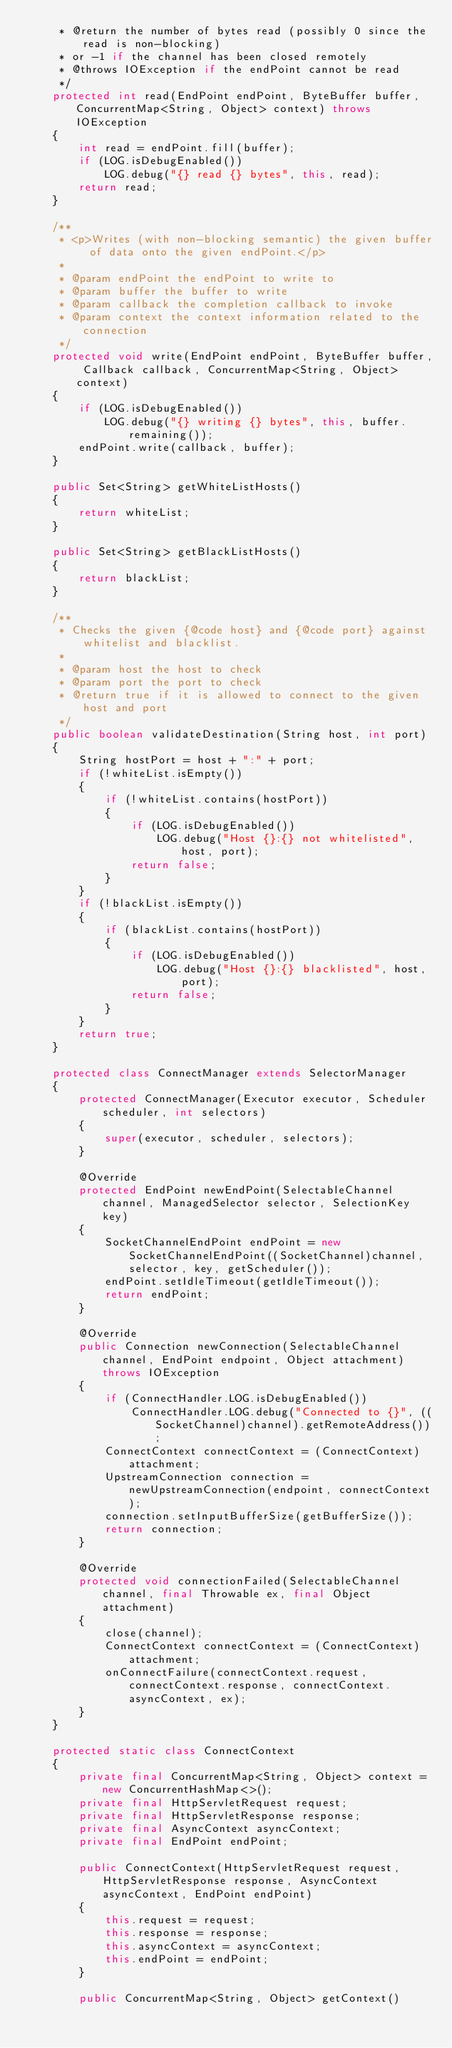Convert code to text. <code><loc_0><loc_0><loc_500><loc_500><_Java_>     * @return the number of bytes read (possibly 0 since the read is non-blocking)
     * or -1 if the channel has been closed remotely
     * @throws IOException if the endPoint cannot be read
     */
    protected int read(EndPoint endPoint, ByteBuffer buffer, ConcurrentMap<String, Object> context) throws IOException
    {
        int read = endPoint.fill(buffer);
        if (LOG.isDebugEnabled())
            LOG.debug("{} read {} bytes", this, read);
        return read;
    }

    /**
     * <p>Writes (with non-blocking semantic) the given buffer of data onto the given endPoint.</p>
     *
     * @param endPoint the endPoint to write to
     * @param buffer the buffer to write
     * @param callback the completion callback to invoke
     * @param context the context information related to the connection
     */
    protected void write(EndPoint endPoint, ByteBuffer buffer, Callback callback, ConcurrentMap<String, Object> context)
    {
        if (LOG.isDebugEnabled())
            LOG.debug("{} writing {} bytes", this, buffer.remaining());
        endPoint.write(callback, buffer);
    }

    public Set<String> getWhiteListHosts()
    {
        return whiteList;
    }

    public Set<String> getBlackListHosts()
    {
        return blackList;
    }

    /**
     * Checks the given {@code host} and {@code port} against whitelist and blacklist.
     *
     * @param host the host to check
     * @param port the port to check
     * @return true if it is allowed to connect to the given host and port
     */
    public boolean validateDestination(String host, int port)
    {
        String hostPort = host + ":" + port;
        if (!whiteList.isEmpty())
        {
            if (!whiteList.contains(hostPort))
            {
                if (LOG.isDebugEnabled())
                    LOG.debug("Host {}:{} not whitelisted", host, port);
                return false;
            }
        }
        if (!blackList.isEmpty())
        {
            if (blackList.contains(hostPort))
            {
                if (LOG.isDebugEnabled())
                    LOG.debug("Host {}:{} blacklisted", host, port);
                return false;
            }
        }
        return true;
    }

    protected class ConnectManager extends SelectorManager
    {
        protected ConnectManager(Executor executor, Scheduler scheduler, int selectors)
        {
            super(executor, scheduler, selectors);
        }

        @Override
        protected EndPoint newEndPoint(SelectableChannel channel, ManagedSelector selector, SelectionKey key)
        {
            SocketChannelEndPoint endPoint = new SocketChannelEndPoint((SocketChannel)channel, selector, key, getScheduler());
            endPoint.setIdleTimeout(getIdleTimeout());
            return endPoint;
        }

        @Override
        public Connection newConnection(SelectableChannel channel, EndPoint endpoint, Object attachment) throws IOException
        {
            if (ConnectHandler.LOG.isDebugEnabled())
                ConnectHandler.LOG.debug("Connected to {}", ((SocketChannel)channel).getRemoteAddress());
            ConnectContext connectContext = (ConnectContext)attachment;
            UpstreamConnection connection = newUpstreamConnection(endpoint, connectContext);
            connection.setInputBufferSize(getBufferSize());
            return connection;
        }

        @Override
        protected void connectionFailed(SelectableChannel channel, final Throwable ex, final Object attachment)
        {
            close(channel);
            ConnectContext connectContext = (ConnectContext)attachment;
            onConnectFailure(connectContext.request, connectContext.response, connectContext.asyncContext, ex);
        }
    }

    protected static class ConnectContext
    {
        private final ConcurrentMap<String, Object> context = new ConcurrentHashMap<>();
        private final HttpServletRequest request;
        private final HttpServletResponse response;
        private final AsyncContext asyncContext;
        private final EndPoint endPoint;

        public ConnectContext(HttpServletRequest request, HttpServletResponse response, AsyncContext asyncContext, EndPoint endPoint)
        {
            this.request = request;
            this.response = response;
            this.asyncContext = asyncContext;
            this.endPoint = endPoint;
        }

        public ConcurrentMap<String, Object> getContext()</code> 